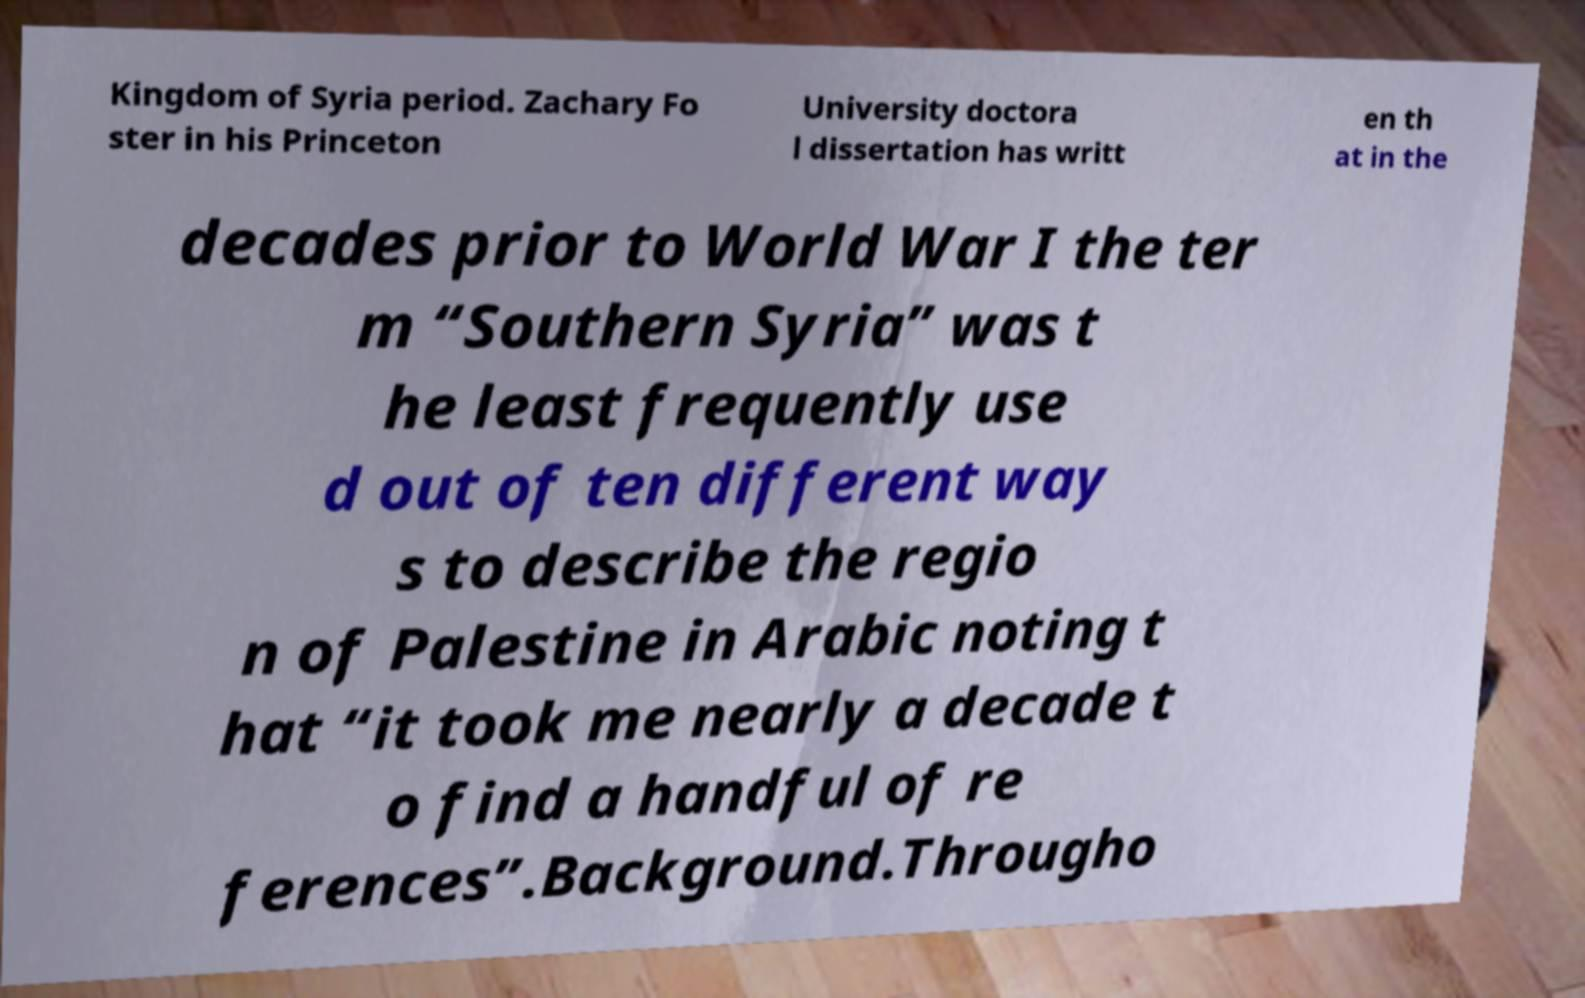There's text embedded in this image that I need extracted. Can you transcribe it verbatim? Kingdom of Syria period. Zachary Fo ster in his Princeton University doctora l dissertation has writt en th at in the decades prior to World War I the ter m “Southern Syria” was t he least frequently use d out of ten different way s to describe the regio n of Palestine in Arabic noting t hat “it took me nearly a decade t o find a handful of re ferences”.Background.Througho 